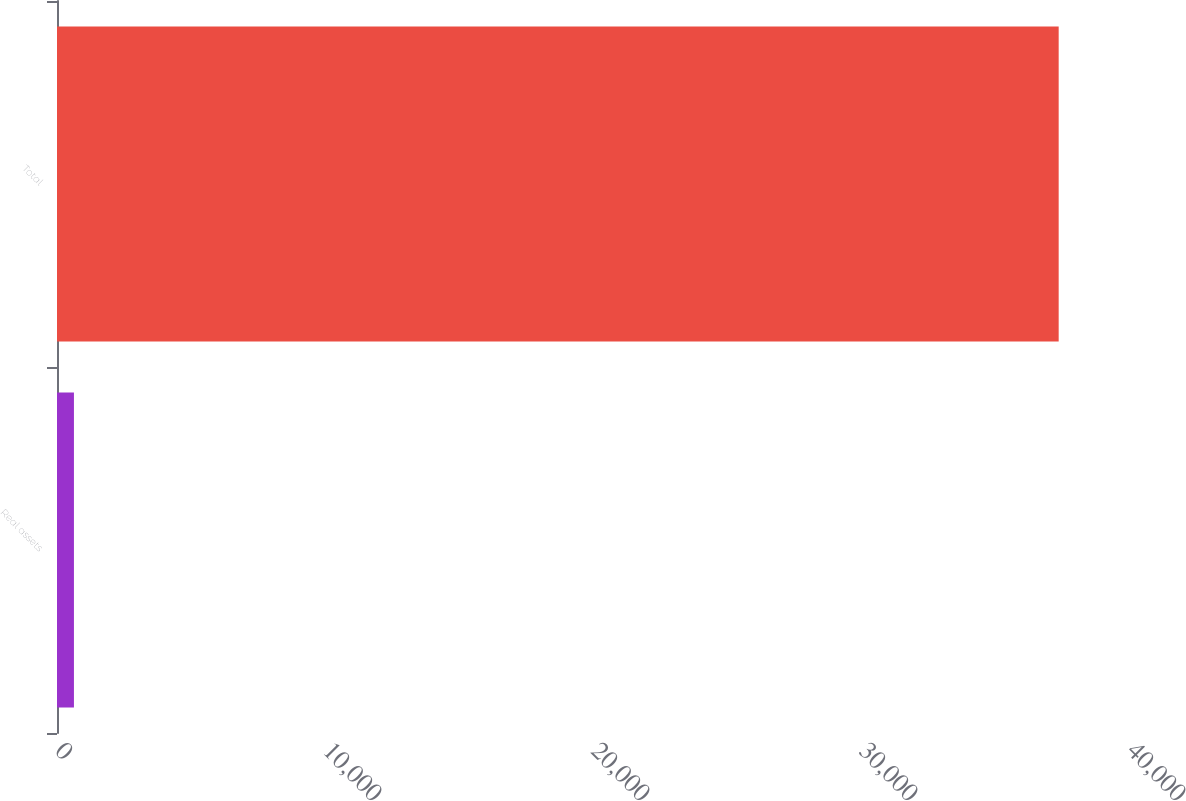<chart> <loc_0><loc_0><loc_500><loc_500><bar_chart><fcel>Real assets<fcel>Total<nl><fcel>632<fcel>37376<nl></chart> 